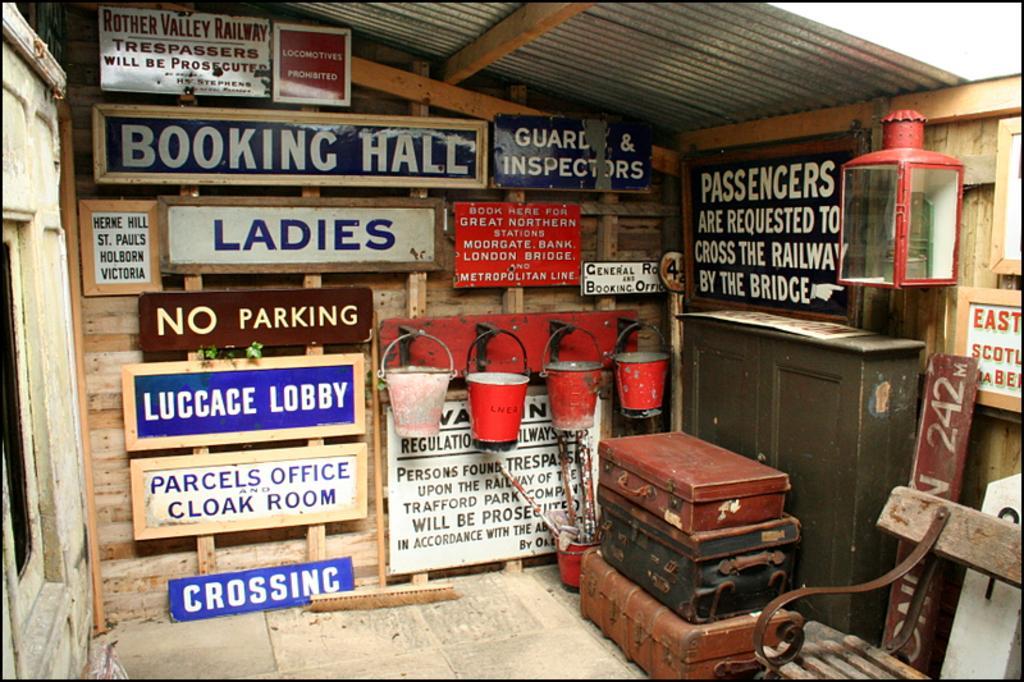How would you summarize this image in a sentence or two? There are three suitcases on the right side. There are four buckets which are fixed to the hanger. This is a wooden chair. These are wooden hoardings. 